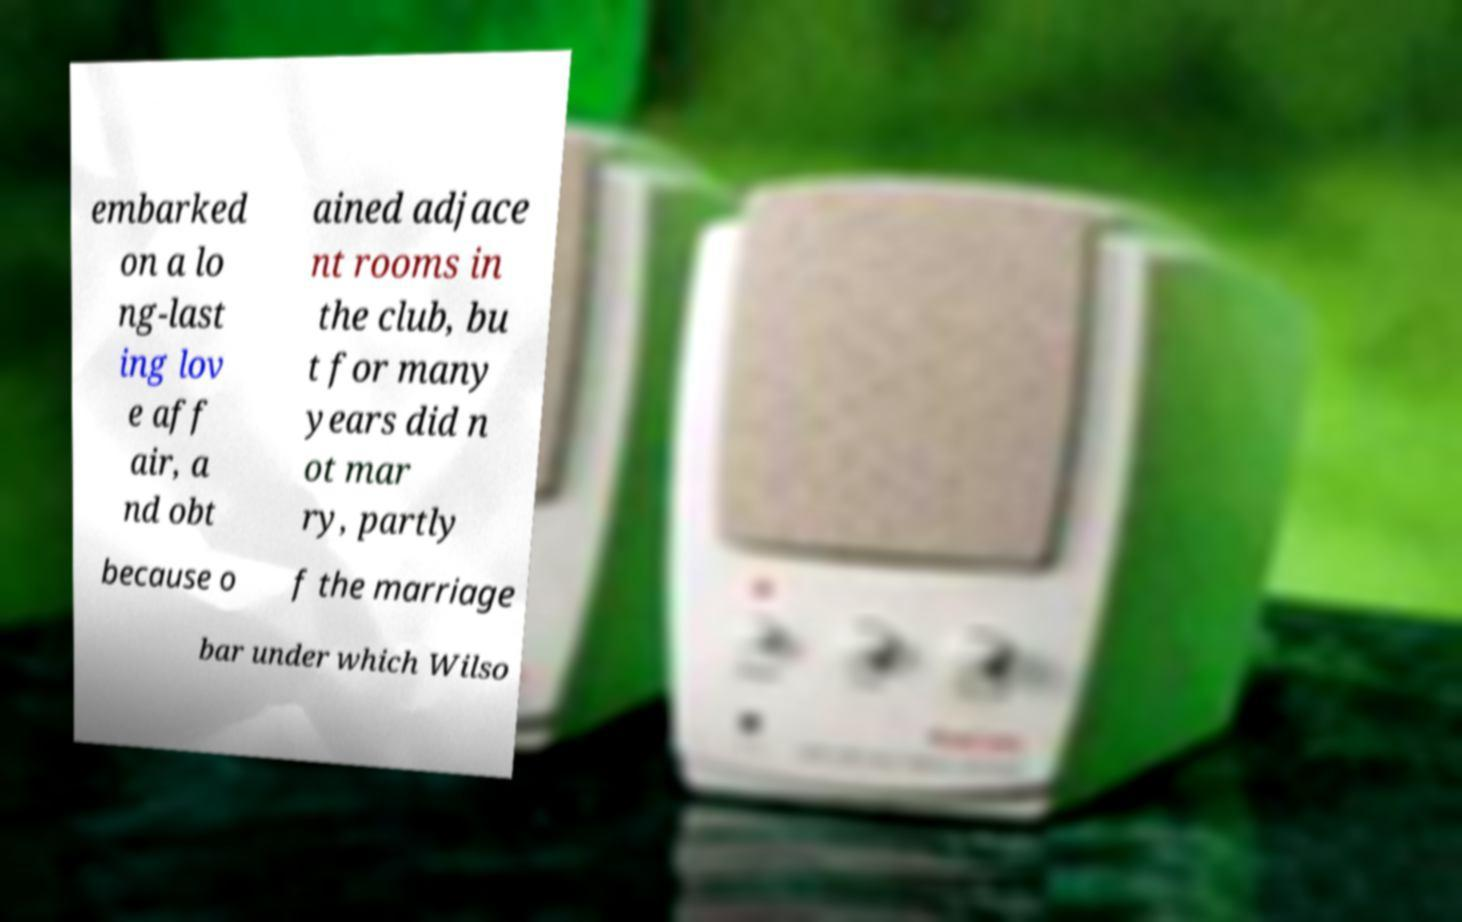What messages or text are displayed in this image? I need them in a readable, typed format. embarked on a lo ng-last ing lov e aff air, a nd obt ained adjace nt rooms in the club, bu t for many years did n ot mar ry, partly because o f the marriage bar under which Wilso 